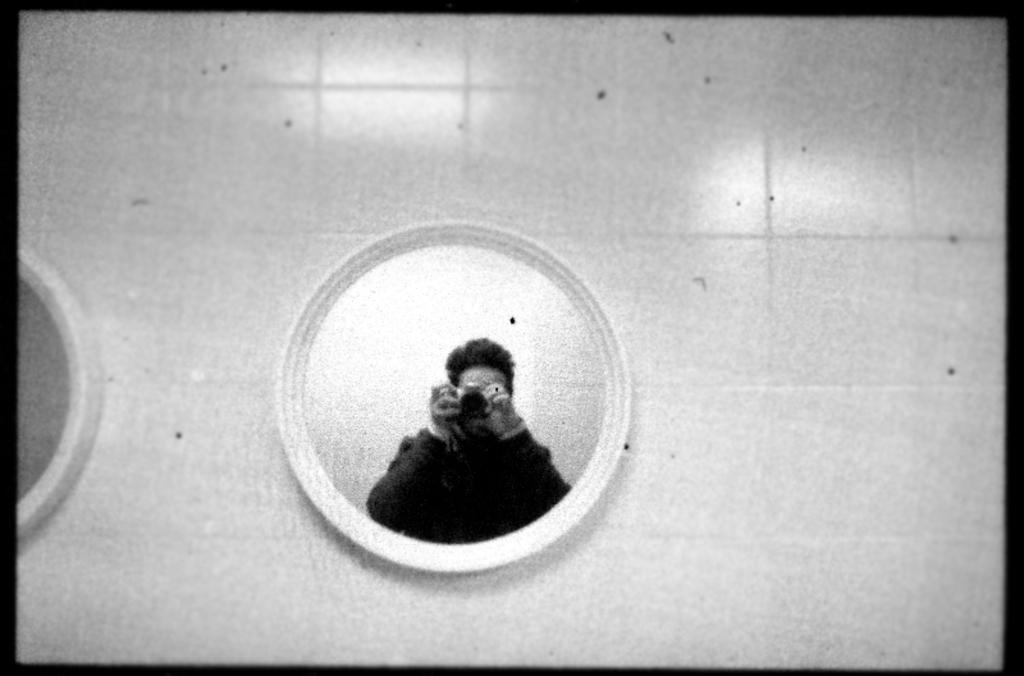What type of flooring is visible in the image? There are white color tiles in the image. What other objects can be seen in the image? There are mirrors in the image. What does the mirror reflect in the image? The mirror reflects a man wearing a black color jacket. What is the man holding in the reflection? The man is holding a camera in the reflection. What is the price of the lunchroom in the image? There is no lunchroom present in the image, so it is not possible to determine its price. 